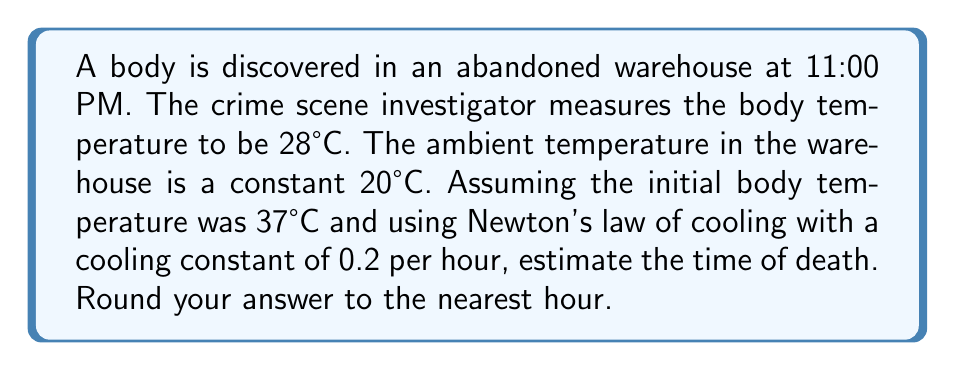Could you help me with this problem? To solve this problem, we'll use Newton's law of cooling and the given information:

1) Let $T(t)$ be the temperature of the body at time $t$, $T_a$ the ambient temperature, and $T_0$ the initial body temperature.

2) Newton's law of cooling is given by the differential equation:

   $$\frac{dT}{dt} = -k(T - T_a)$$

   where $k$ is the cooling constant.

3) The solution to this differential equation is:

   $$T(t) = T_a + (T_0 - T_a)e^{-kt}$$

4) We know:
   - $T_a = 20°C$ (ambient temperature)
   - $T_0 = 37°C$ (initial body temperature)
   - $T(t) = 28°C$ (current body temperature)
   - $k = 0.2$ per hour (cooling constant)

5) Substituting these values into the equation:

   $$28 = 20 + (37 - 20)e^{-0.2t}$$

6) Simplifying:

   $$8 = 17e^{-0.2t}$$

7) Dividing both sides by 17:

   $$\frac{8}{17} = e^{-0.2t}$$

8) Taking the natural logarithm of both sides:

   $$\ln(\frac{8}{17}) = -0.2t$$

9) Solving for $t$:

   $$t = -\frac{\ln(\frac{8}{17})}{0.2} \approx 3.76 \text{ hours}$$

10) Rounding to the nearest hour:

    $t \approx 4 \text{ hours}$

11) Since the body was discovered at 11:00 PM, we subtract 4 hours to get the estimated time of death: 7:00 PM.
Answer: The estimated time of death is 7:00 PM. 